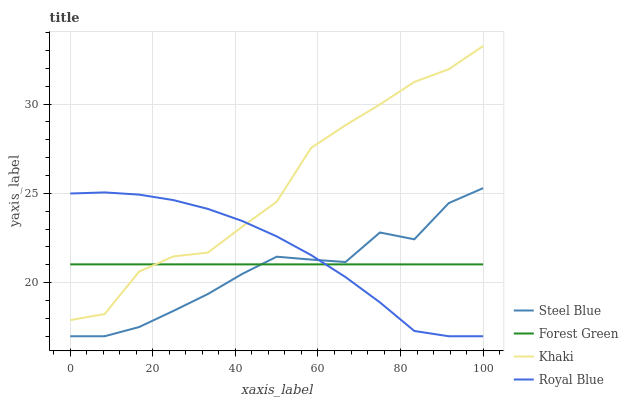Does Steel Blue have the minimum area under the curve?
Answer yes or no. Yes. Does Khaki have the maximum area under the curve?
Answer yes or no. Yes. Does Forest Green have the minimum area under the curve?
Answer yes or no. No. Does Forest Green have the maximum area under the curve?
Answer yes or no. No. Is Forest Green the smoothest?
Answer yes or no. Yes. Is Khaki the roughest?
Answer yes or no. Yes. Is Khaki the smoothest?
Answer yes or no. No. Is Forest Green the roughest?
Answer yes or no. No. Does Royal Blue have the lowest value?
Answer yes or no. Yes. Does Khaki have the lowest value?
Answer yes or no. No. Does Khaki have the highest value?
Answer yes or no. Yes. Does Forest Green have the highest value?
Answer yes or no. No. Is Steel Blue less than Khaki?
Answer yes or no. Yes. Is Khaki greater than Steel Blue?
Answer yes or no. Yes. Does Steel Blue intersect Royal Blue?
Answer yes or no. Yes. Is Steel Blue less than Royal Blue?
Answer yes or no. No. Is Steel Blue greater than Royal Blue?
Answer yes or no. No. Does Steel Blue intersect Khaki?
Answer yes or no. No. 